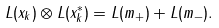<formula> <loc_0><loc_0><loc_500><loc_500>L ( x _ { k } ) \otimes L ( x _ { k } ^ { * } ) = L ( m _ { + } ) + L ( m _ { - } ) .</formula> 